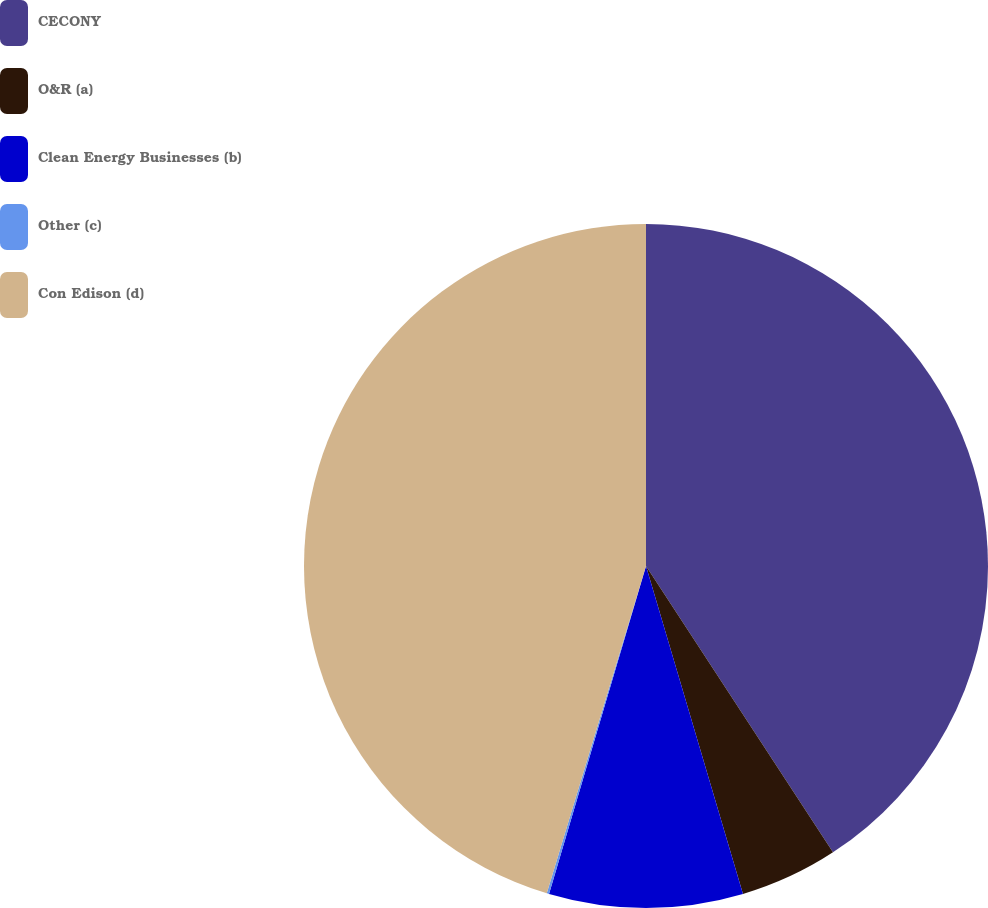Convert chart to OTSL. <chart><loc_0><loc_0><loc_500><loc_500><pie_chart><fcel>CECONY<fcel>O&R (a)<fcel>Clean Energy Businesses (b)<fcel>Other (c)<fcel>Con Edison (d)<nl><fcel>40.79%<fcel>4.63%<fcel>9.15%<fcel>0.11%<fcel>45.31%<nl></chart> 